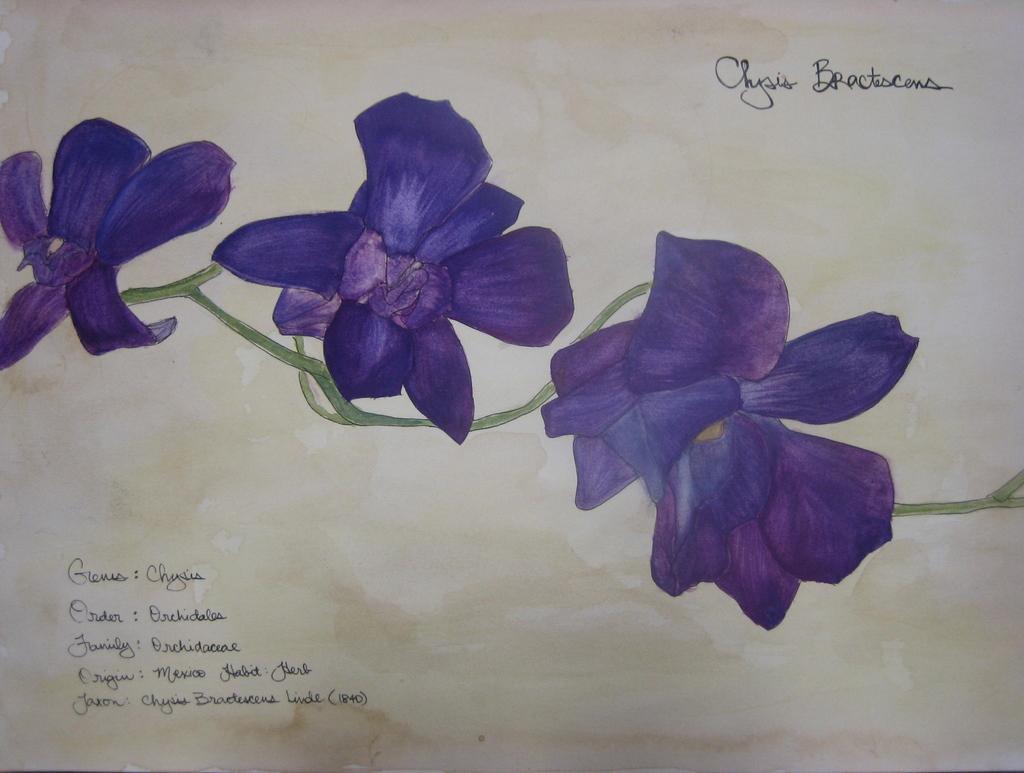How would you summarize this image in a sentence or two? This is a zoomed in picture and there is a painting of flowers and we can see the text is written on the image. 